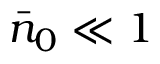Convert formula to latex. <formula><loc_0><loc_0><loc_500><loc_500>\bar { n } _ { 0 } \ll 1</formula> 